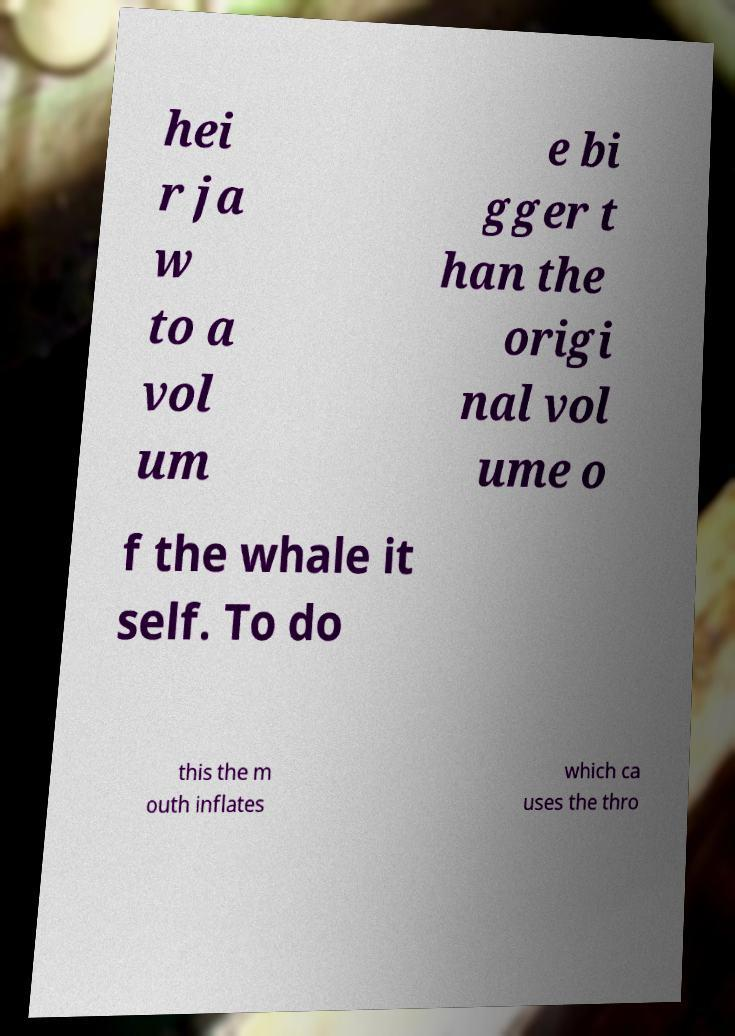Can you accurately transcribe the text from the provided image for me? hei r ja w to a vol um e bi gger t han the origi nal vol ume o f the whale it self. To do this the m outh inflates which ca uses the thro 